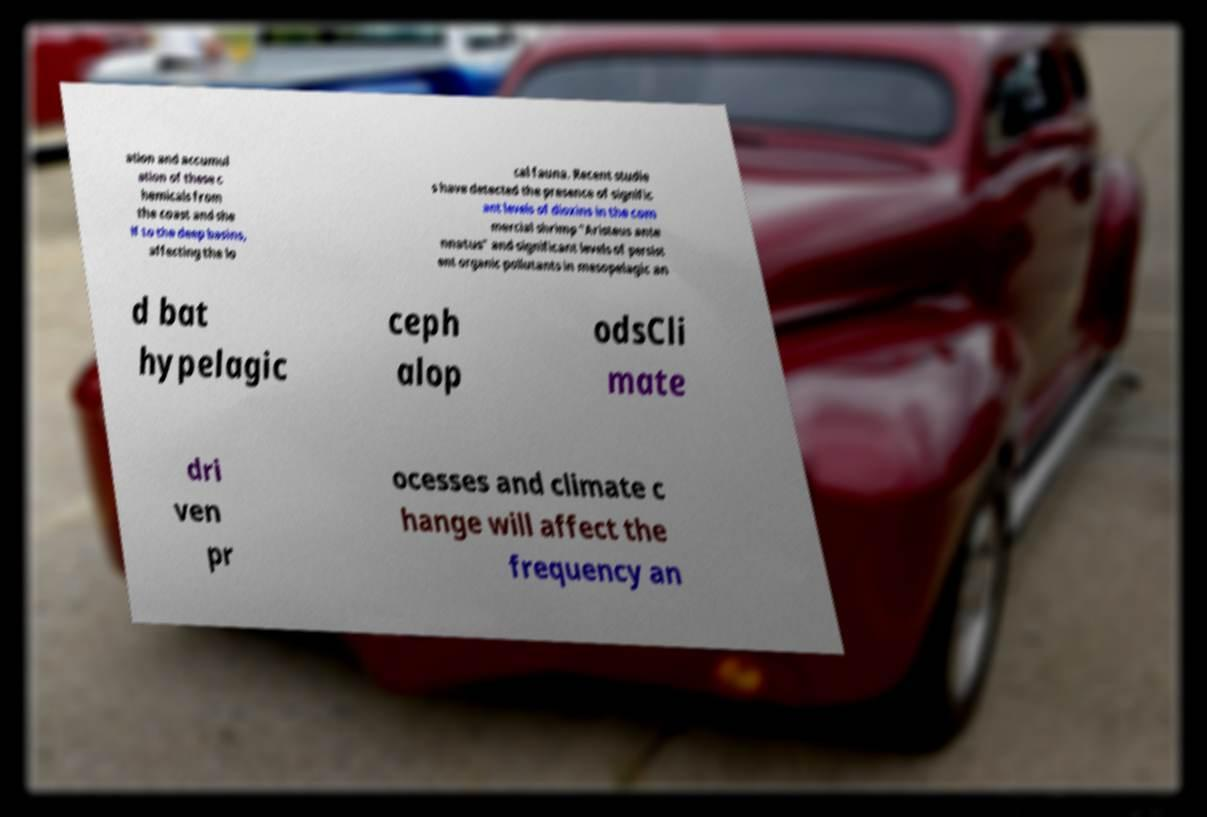I need the written content from this picture converted into text. Can you do that? ation and accumul ation of these c hemicals from the coast and she lf to the deep basins, affecting the lo cal fauna. Recent studie s have detected the presence of signific ant levels of dioxins in the com mercial shrimp "Aristeus ante nnatus" and significant levels of persist ent organic pollutants in mesopelagic an d bat hypelagic ceph alop odsCli mate dri ven pr ocesses and climate c hange will affect the frequency an 